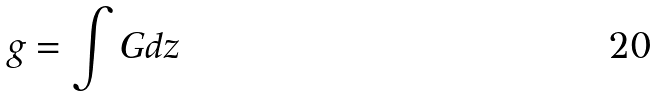<formula> <loc_0><loc_0><loc_500><loc_500>g = \int G d z</formula> 